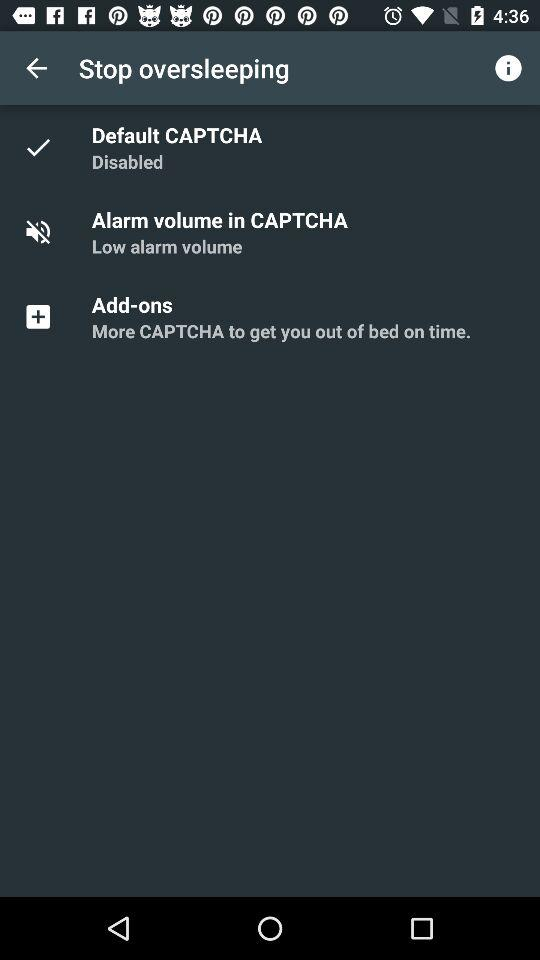How many CAPTCHAs are disabled?
Answer the question using a single word or phrase. 1 